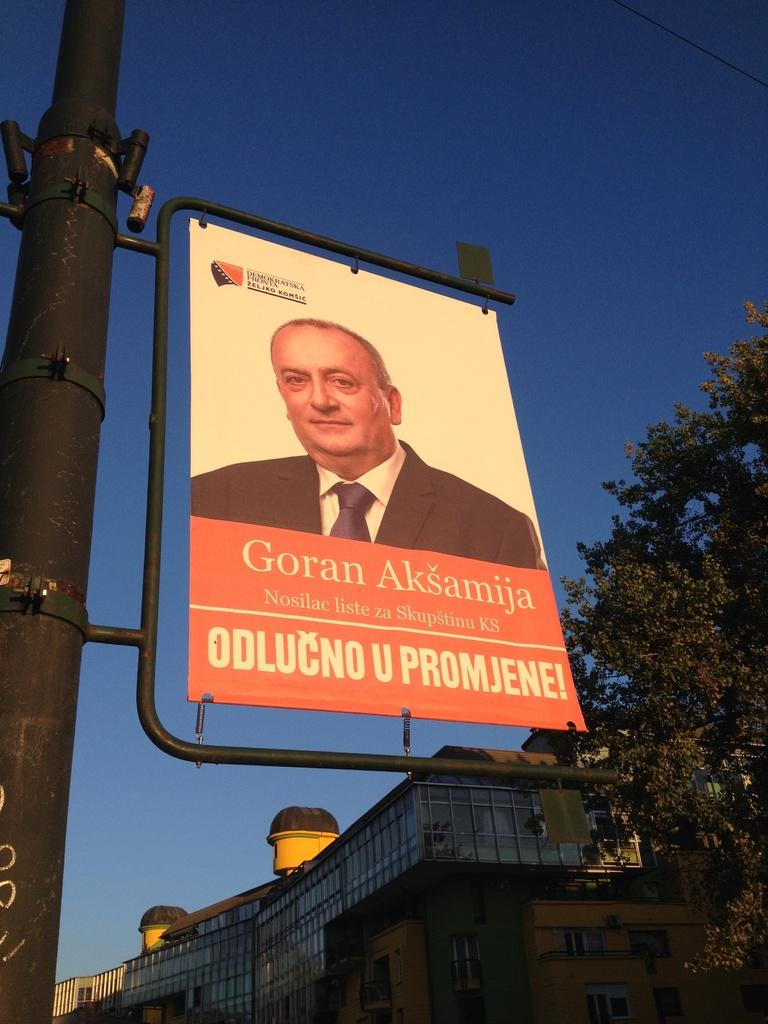<image>
Provide a brief description of the given image. A sign featuring Goran Aksamija hangs on a post. 